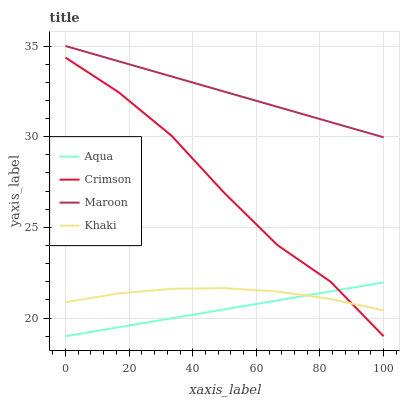Does Aqua have the minimum area under the curve?
Answer yes or no. Yes. Does Maroon have the maximum area under the curve?
Answer yes or no. Yes. Does Khaki have the minimum area under the curve?
Answer yes or no. No. Does Khaki have the maximum area under the curve?
Answer yes or no. No. Is Aqua the smoothest?
Answer yes or no. Yes. Is Crimson the roughest?
Answer yes or no. Yes. Is Khaki the smoothest?
Answer yes or no. No. Is Khaki the roughest?
Answer yes or no. No. Does Khaki have the lowest value?
Answer yes or no. No. Does Maroon have the highest value?
Answer yes or no. Yes. Does Aqua have the highest value?
Answer yes or no. No. Is Aqua less than Maroon?
Answer yes or no. Yes. Is Maroon greater than Khaki?
Answer yes or no. Yes. Does Khaki intersect Crimson?
Answer yes or no. Yes. Is Khaki less than Crimson?
Answer yes or no. No. Is Khaki greater than Crimson?
Answer yes or no. No. Does Aqua intersect Maroon?
Answer yes or no. No. 